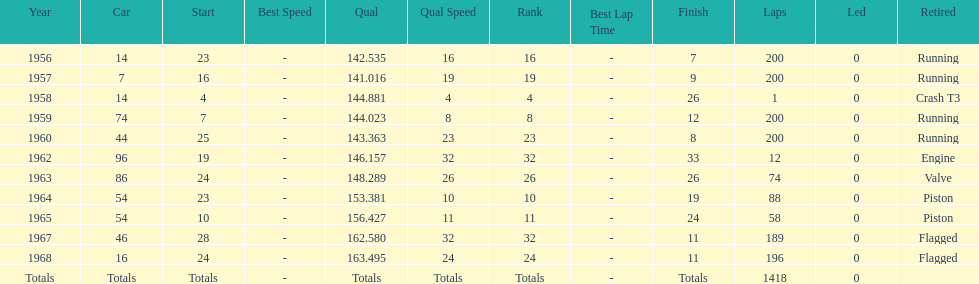What was the last year that it finished the race? 1968. 